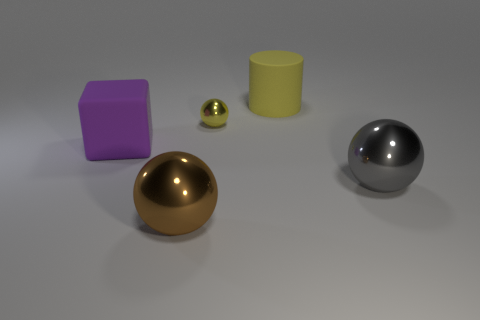Are there fewer brown blocks than big purple things?
Your answer should be very brief. Yes. What size is the object that is in front of the yellow cylinder and behind the purple cube?
Keep it short and to the point. Small. There is a gray ball in front of the yellow object that is on the left side of the big object that is behind the purple rubber block; what is its size?
Keep it short and to the point. Large. What number of other things are the same color as the cylinder?
Provide a short and direct response. 1. There is a big matte object behind the block; is its color the same as the small thing?
Your response must be concise. Yes. How many things are either yellow cylinders or big brown shiny balls?
Give a very brief answer. 2. What is the color of the large object that is left of the large brown thing?
Give a very brief answer. Purple. Is the number of large gray metallic spheres that are left of the purple object less than the number of tiny rubber things?
Provide a succinct answer. No. The other object that is the same color as the small thing is what size?
Your response must be concise. Large. Is there any other thing that has the same size as the purple matte block?
Ensure brevity in your answer.  Yes. 